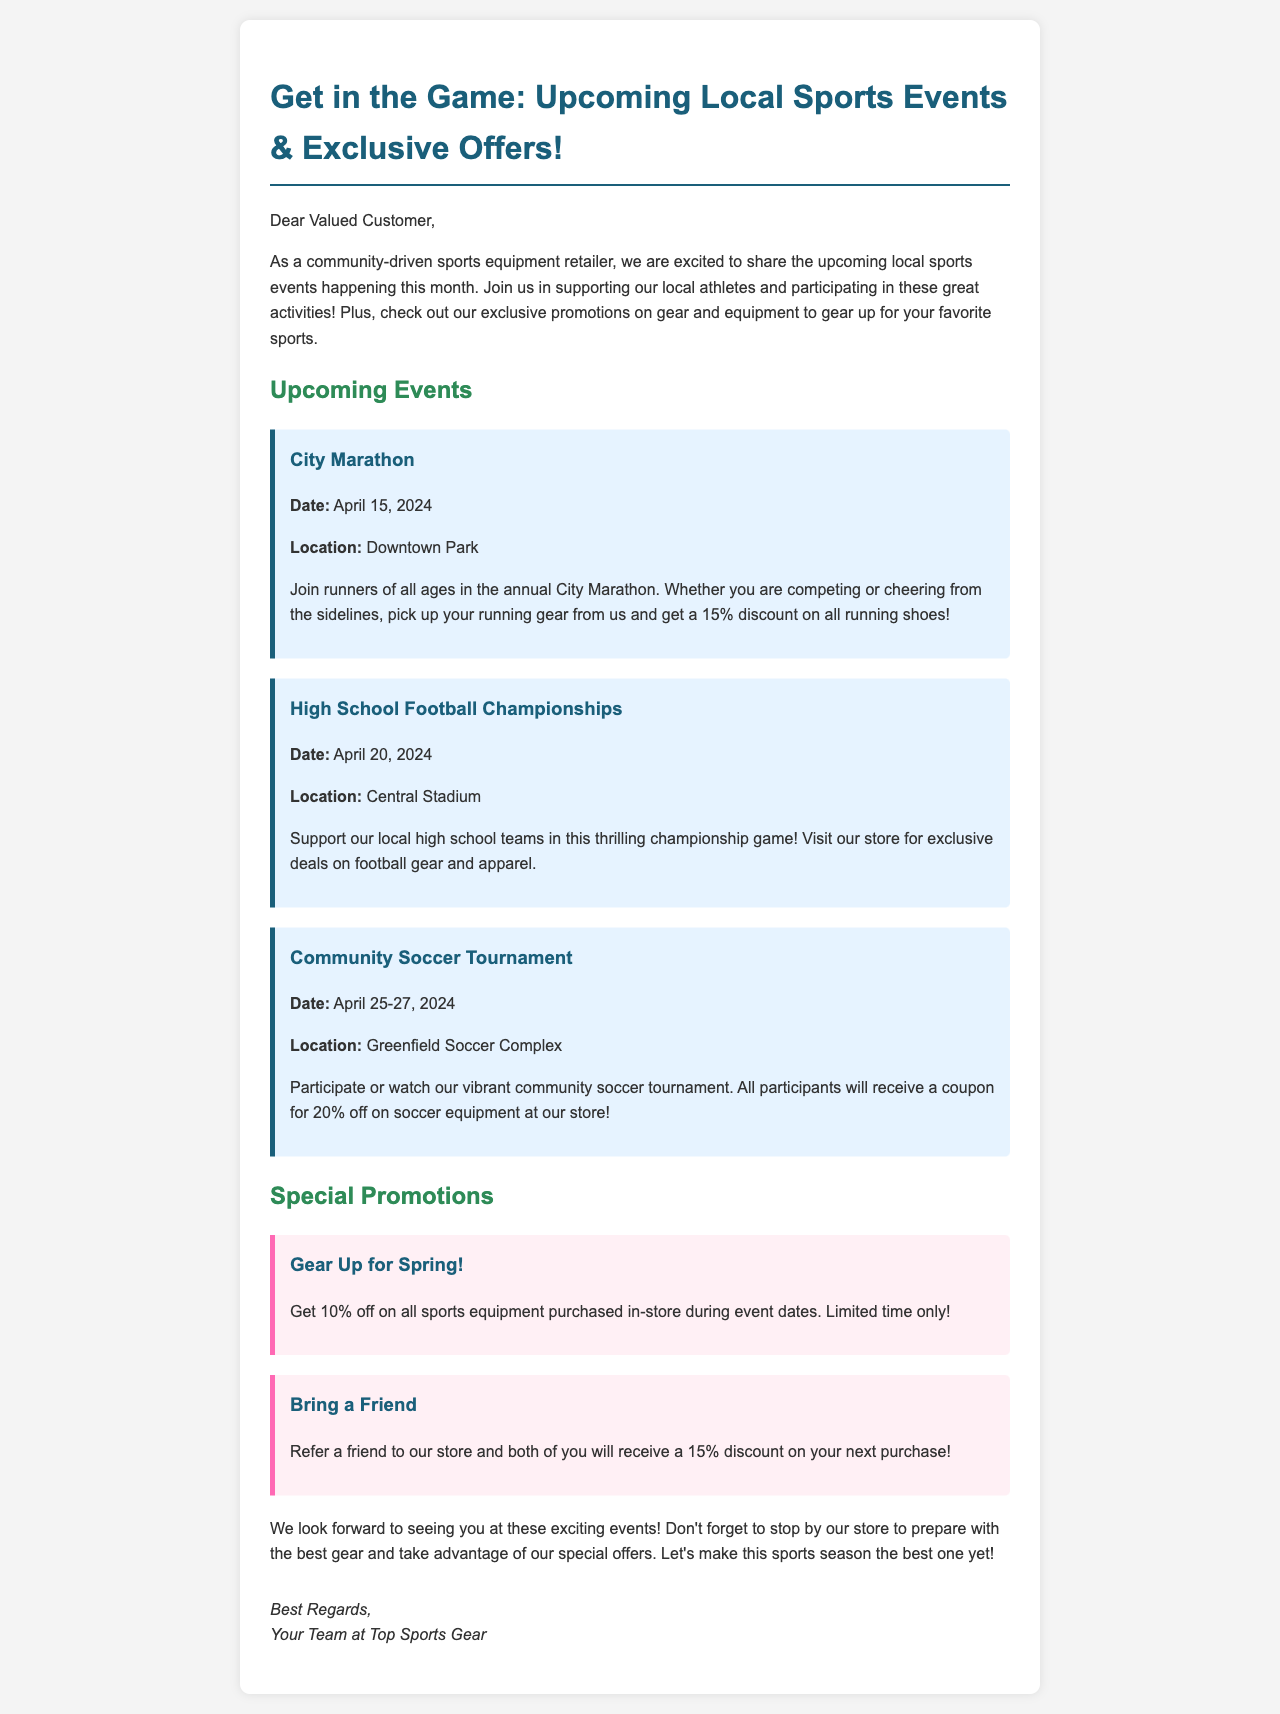What is the title of the newsletter? The title of the newsletter is prominently displayed at the top of the document.
Answer: Get in the Game: Upcoming Local Sports Events & Exclusive Offers! When is the City Marathon taking place? The date of the City Marathon is clearly mentioned in the event details section.
Answer: April 15, 2024 Where will the Community Soccer Tournament be held? The location for the Community Soccer Tournament can be found in the event details.
Answer: Greenfield Soccer Complex What discount is offered on running shoes during the City Marathon? The specific discount for running shoes is stated in the event description.
Answer: 15% What is the special promotion for in-store purchases during event dates? The details of the special promotion can be found in the promotions section of the newsletter.
Answer: 10% off What should customers do to receive a discount when referring a friend? The requirements for the "Bring a Friend" promotion are explicitly stated in the promotions section.
Answer: Refer a friend How many days will the Community Soccer Tournament last? The duration of the Community Soccer Tournament is mentioned in the event description.
Answer: 3 days What is the main purpose of the newsletter? The main purpose of the newsletter is outlined in the introductory paragraph.
Answer: Share upcoming local sports events and promotions What color is used for the subheading of "Special Promotions"? The color used for the heading can be identified in the styling elements of the document.
Answer: Green 